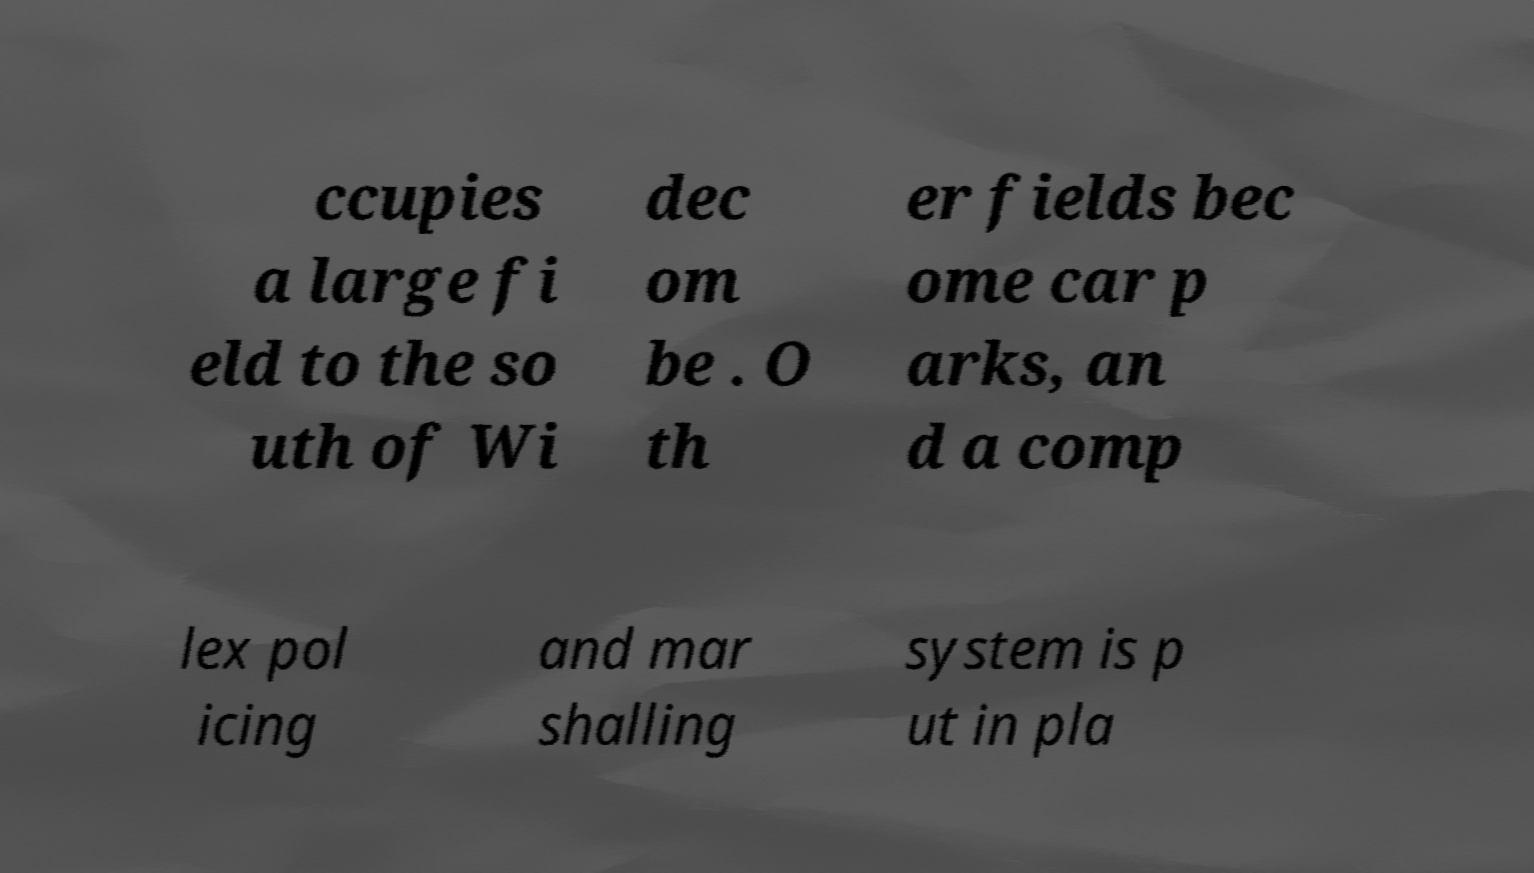Could you extract and type out the text from this image? ccupies a large fi eld to the so uth of Wi dec om be . O th er fields bec ome car p arks, an d a comp lex pol icing and mar shalling system is p ut in pla 